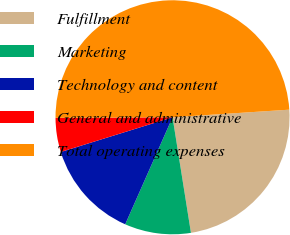<chart> <loc_0><loc_0><loc_500><loc_500><pie_chart><fcel>Fulfillment<fcel>Marketing<fcel>Technology and content<fcel>General and administrative<fcel>Total operating expenses<nl><fcel>23.52%<fcel>9.14%<fcel>13.58%<fcel>4.71%<fcel>49.04%<nl></chart> 